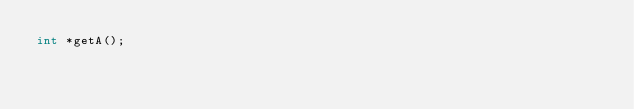<code> <loc_0><loc_0><loc_500><loc_500><_C_>int *getA();

</code> 